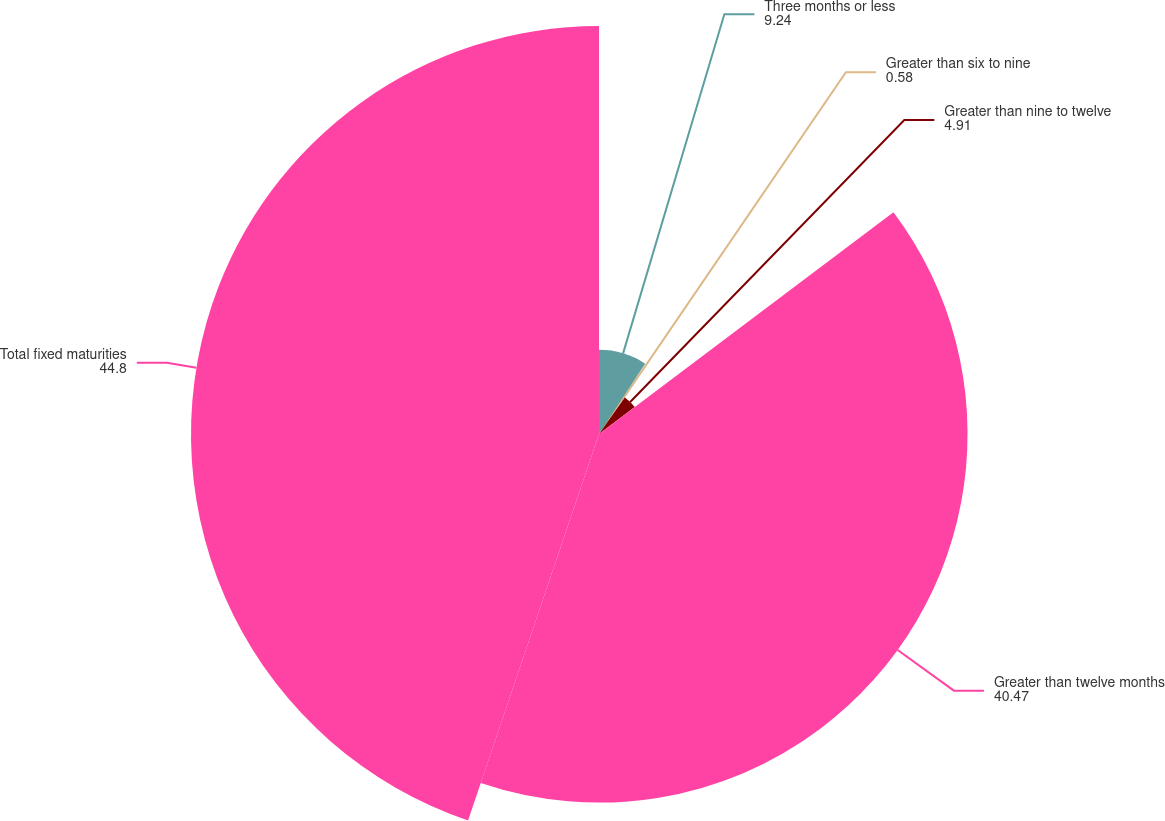Convert chart. <chart><loc_0><loc_0><loc_500><loc_500><pie_chart><fcel>Three months or less<fcel>Greater than six to nine<fcel>Greater than nine to twelve<fcel>Greater than twelve months<fcel>Total fixed maturities<nl><fcel>9.24%<fcel>0.58%<fcel>4.91%<fcel>40.47%<fcel>44.8%<nl></chart> 